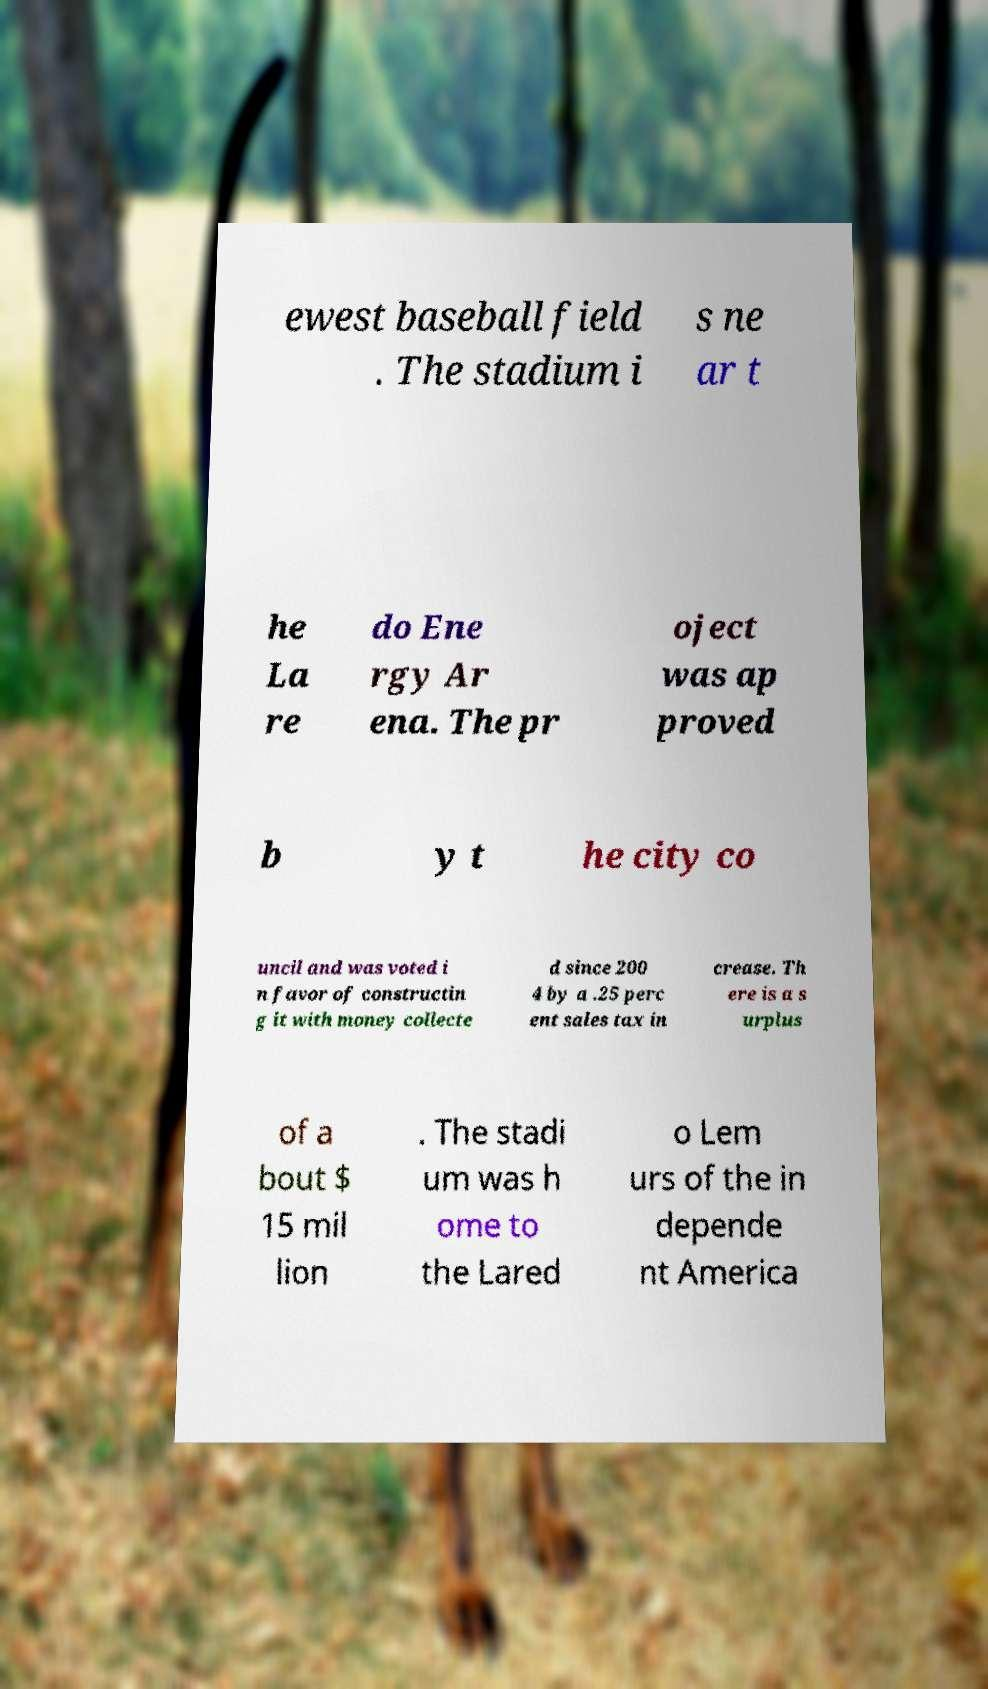Could you extract and type out the text from this image? ewest baseball field . The stadium i s ne ar t he La re do Ene rgy Ar ena. The pr oject was ap proved b y t he city co uncil and was voted i n favor of constructin g it with money collecte d since 200 4 by a .25 perc ent sales tax in crease. Th ere is a s urplus of a bout $ 15 mil lion . The stadi um was h ome to the Lared o Lem urs of the in depende nt America 